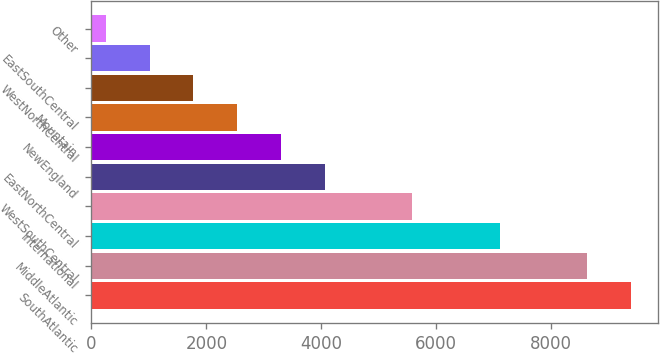Convert chart. <chart><loc_0><loc_0><loc_500><loc_500><bar_chart><fcel>SouthAtlantic<fcel>MiddleAtlantic<fcel>International<fcel>WestSouthCentral<fcel>EastNorthCentral<fcel>NewEngland<fcel>Mountain<fcel>WestNorthCentral<fcel>EastSouthCentral<fcel>Other<nl><fcel>9394<fcel>8632<fcel>7108<fcel>5584<fcel>4060<fcel>3298<fcel>2536<fcel>1774<fcel>1012<fcel>250<nl></chart> 